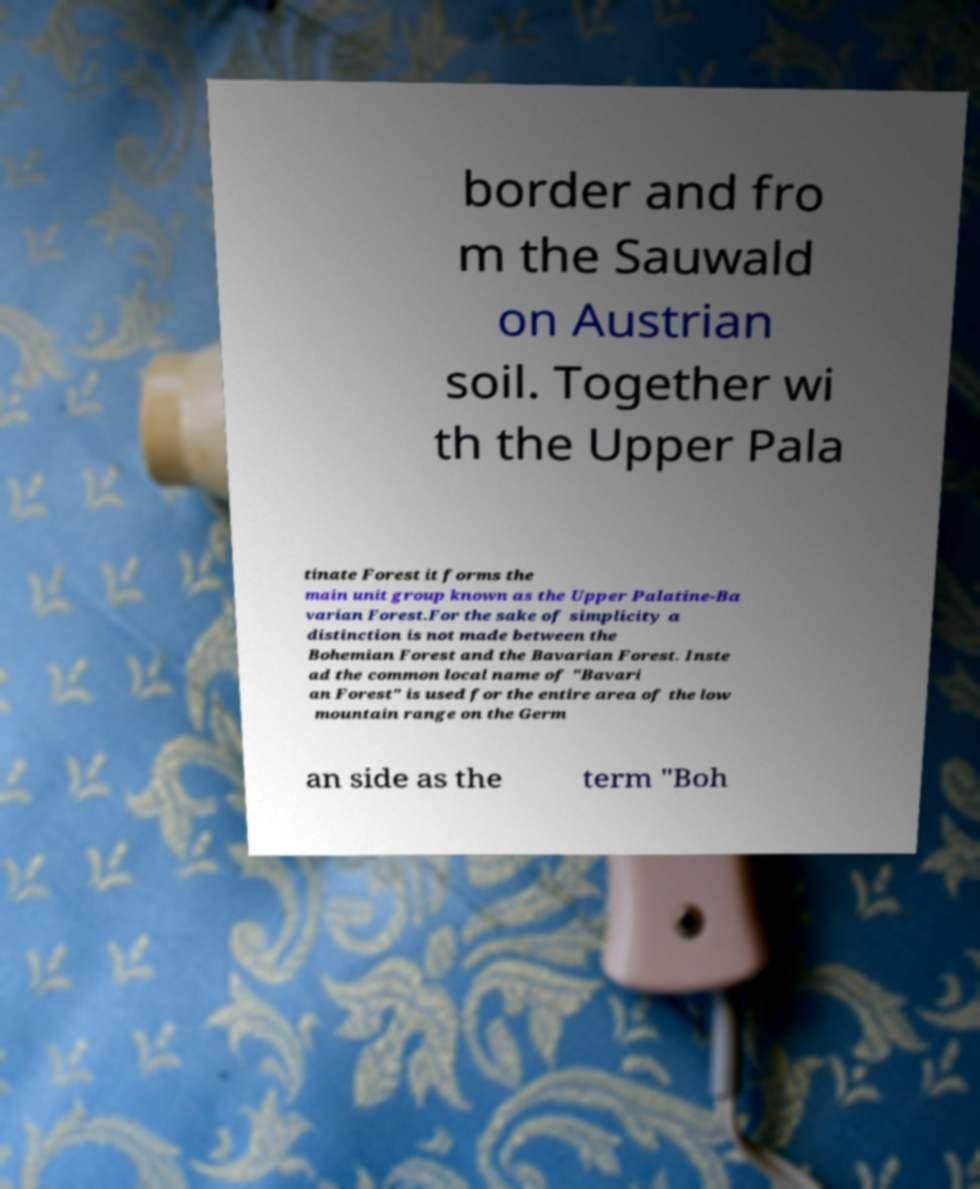Please identify and transcribe the text found in this image. border and fro m the Sauwald on Austrian soil. Together wi th the Upper Pala tinate Forest it forms the main unit group known as the Upper Palatine-Ba varian Forest.For the sake of simplicity a distinction is not made between the Bohemian Forest and the Bavarian Forest. Inste ad the common local name of "Bavari an Forest" is used for the entire area of the low mountain range on the Germ an side as the term "Boh 